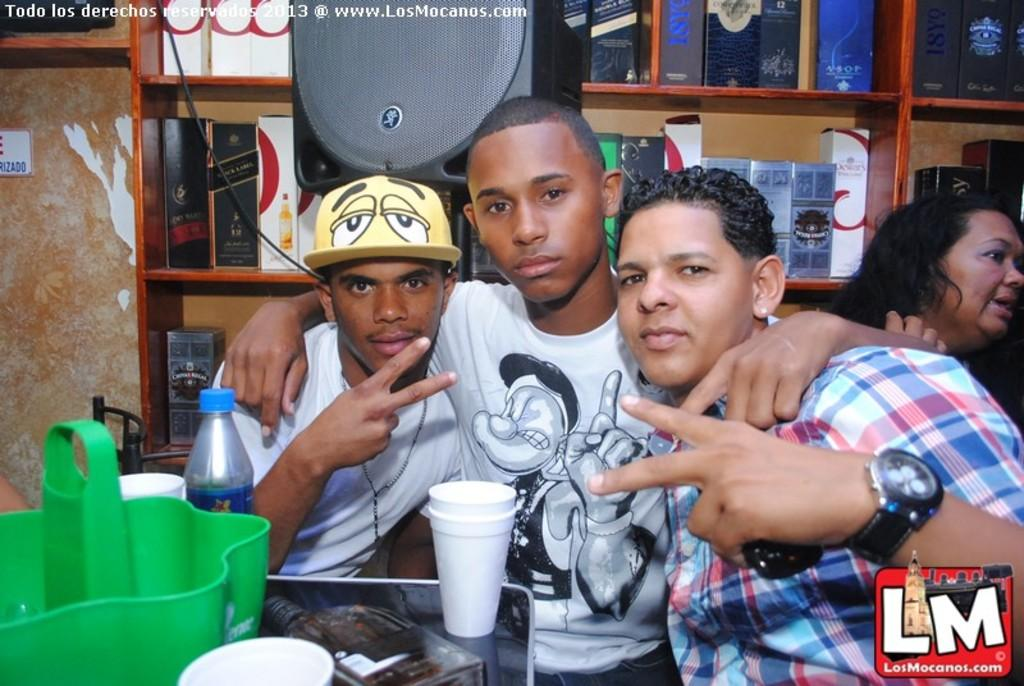How many people are in the image? There is a group of people in the image. What are the people in the image doing? The people are standing together. What can be seen on the shelf in the image? The shelf contains alcohol bottles. What type of jar is being used for religious purposes in the image? There is no jar present in the image, and no religious practices are depicted. 